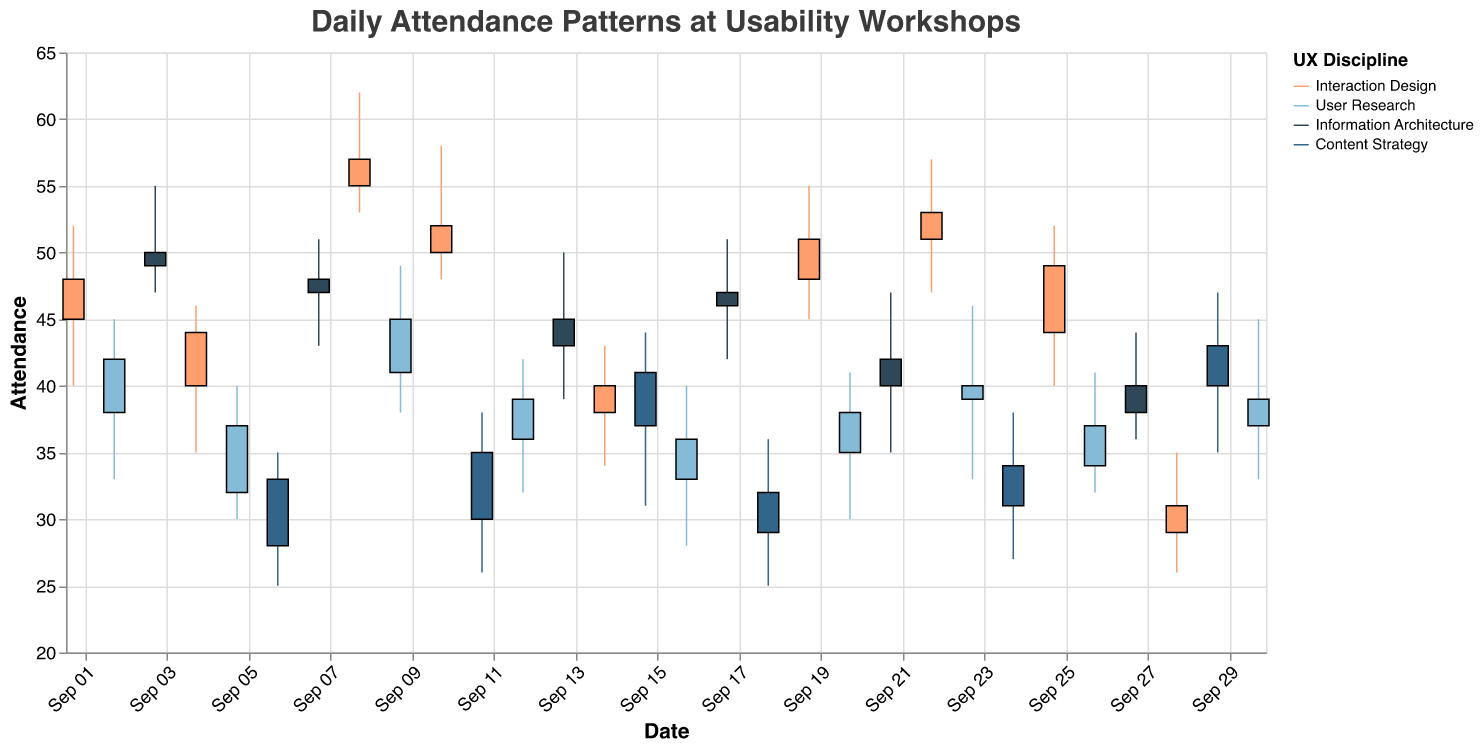What is the title of the figure? The title of the figure is typically found at the top center of the chart. In this case, the title text is "Daily Attendance Patterns at Usability Workshops."
Answer: Daily Attendance Patterns at Usability Workshops Which discipline had the highest opening attendance on September 8? To determine this, look at the data for September 8. The workshop on that date is "Advanced Interaction Design," which is classified under "Interaction Design." The Open attendance for this day is 55.
Answer: Interaction Design On which date did the "UX Strategy & Planning" workshop occur, and what was its closing attendance? By looking at the data, we can find that "UX Strategy & Planning" is listed on September 11 with a Close value of 35.
Answer: September 11, 35 Which discipline saw the greatest volatility (difference between high and low attendance) on any single day, and what was the value of that volatility? To find the greatest volatility, calculate the difference between High and Low for each entry. The largest difference occurs on September 8 for the "Advanced Interaction Design" workshop under "Interaction Design," with High 62 and Low 53, resulting in a volatility of 9.
Answer: Interaction Design, 9 What is the average closing attendance for "User Research" discipline workshops over the month? List the closing attendance values for all User Research workshops: 42, 37, 45, 39, 36, 38, 40, 37, 39. Sum them up and divide by the number of entries: (42 + 37 + 45 + 39 + 36 + 38 + 40 + 37 + 39) / 9 = 353 / 9 ≈ 39.22.
Answer: 39.22 How many times did the "Interaction Design" discipline have an opening attendance greater than 45? Look at the "Open" column for "Interaction Design" entries: 45, 40, 55, 50, 48, 51, 44, 29, 40. There are three instances where the opening attendance is greater than 45 (55, 50, 48, 51).
Answer: 4 Which workshop within "Content Strategy" had the lowest attendance at any point of the day, and what was that attendance? For Content Strategy discipline, check the "Low" column: 25, 26, 27, 35. The lowest value is 25 on September 18 for the "UX Metrics and KPIs" workshop.
Answer: UX Metrics and KPIs, 25 Compare the average closing attendance between "Interaction Design" and "Information Architecture" disciplines. Which one had a higher average and by how much? Calculate the average closing attendance for both disciplines. Interaction Design: (48 + 44 + 57 + 52 + 51 + 40 + 53 + 49 + 31) / 9 ≈ 47.2. Information Architecture: (49 + 48 + 45 + 47 + 42 + 40) / 6 ≈ 45.2. Interaction Design's average is higher. Difference: 47.2 - 45.2 = 2.
Answer: Interaction Design, 2 What is the range of the "High" attendance values for "User Research" discipline workshops? Find the highest and lowest "High" values for User Research: 45, 40, 49, 42, 40, 41, 46, 41, 45. The maximum value is 49, and the minimum value is 40. The range is 49 - 40 = 9.
Answer: 9 